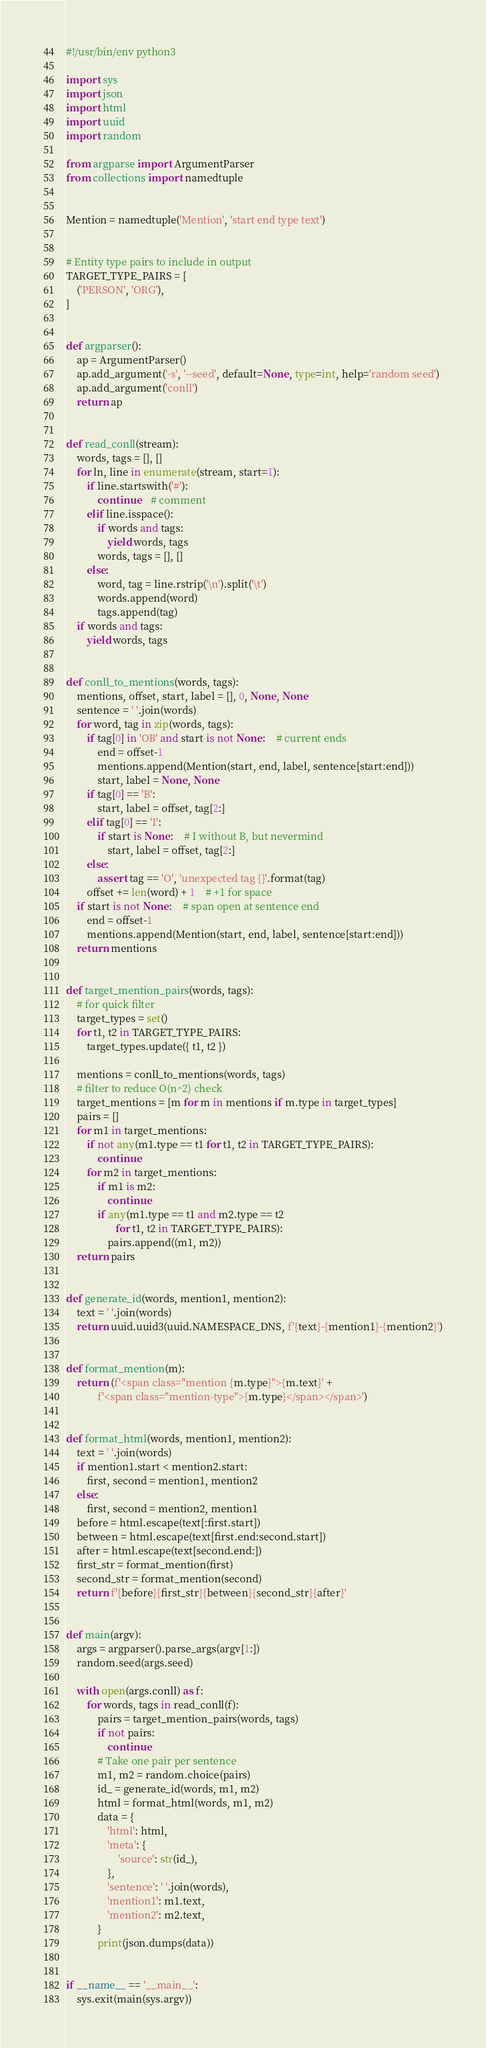<code> <loc_0><loc_0><loc_500><loc_500><_Python_>#!/usr/bin/env python3

import sys
import json
import html
import uuid
import random

from argparse import ArgumentParser
from collections import namedtuple


Mention = namedtuple('Mention', 'start end type text')


# Entity type pairs to include in output
TARGET_TYPE_PAIRS = [
    ('PERSON', 'ORG'),
]


def argparser():
    ap = ArgumentParser()
    ap.add_argument('-s', '--seed', default=None, type=int, help='random seed')
    ap.add_argument('conll')
    return ap


def read_conll(stream):
    words, tags = [], []
    for ln, line in enumerate(stream, start=1):
        if line.startswith('#'):
            continue    # comment
        elif line.isspace():
            if words and tags:
                yield words, tags
            words, tags = [], []
        else:
            word, tag = line.rstrip('\n').split('\t')
            words.append(word)
            tags.append(tag)
    if words and tags:
        yield words, tags


def conll_to_mentions(words, tags):
    mentions, offset, start, label = [], 0, None, None
    sentence = ' '.join(words)
    for word, tag in zip(words, tags):
        if tag[0] in 'OB' and start is not None:    # current ends
            end = offset-1
            mentions.append(Mention(start, end, label, sentence[start:end]))
            start, label = None, None
        if tag[0] == 'B':
            start, label = offset, tag[2:]
        elif tag[0] == 'I':
            if start is None:    # I without B, but nevermind
                start, label = offset, tag[2:]
        else:
            assert tag == 'O', 'unexpected tag {}'.format(tag)
        offset += len(word) + 1    # +1 for space
    if start is not None:    # span open at sentence end
        end = offset-1
        mentions.append(Mention(start, end, label, sentence[start:end]))
    return mentions


def target_mention_pairs(words, tags):
    # for quick filter
    target_types = set()
    for t1, t2 in TARGET_TYPE_PAIRS:
        target_types.update({ t1, t2 })

    mentions = conll_to_mentions(words, tags)
    # filter to reduce O(n^2) check
    target_mentions = [m for m in mentions if m.type in target_types]
    pairs = []
    for m1 in target_mentions:
        if not any(m1.type == t1 for t1, t2 in TARGET_TYPE_PAIRS):
            continue
        for m2 in target_mentions:
            if m1 is m2:
                continue
            if any(m1.type == t1 and m2.type == t2
                   for t1, t2 in TARGET_TYPE_PAIRS):
                pairs.append((m1, m2))
    return pairs


def generate_id(words, mention1, mention2):
    text = ' '.join(words)
    return uuid.uuid3(uuid.NAMESPACE_DNS, f'{text}-{mention1}-{mention2}')


def format_mention(m):
    return (f'<span class="mention {m.type}">{m.text}' +
            f'<span class="mention-type">{m.type}</span></span>')


def format_html(words, mention1, mention2):
    text = ' '.join(words)
    if mention1.start < mention2.start:
        first, second = mention1, mention2
    else:
        first, second = mention2, mention1
    before = html.escape(text[:first.start])
    between = html.escape(text[first.end:second.start])
    after = html.escape(text[second.end:])
    first_str = format_mention(first)
    second_str = format_mention(second)
    return f'{before}{first_str}{between}{second_str}{after}'


def main(argv):
    args = argparser().parse_args(argv[1:])
    random.seed(args.seed)
    
    with open(args.conll) as f:
        for words, tags in read_conll(f):
            pairs = target_mention_pairs(words, tags)
            if not pairs:
                continue
            # Take one pair per sentence
            m1, m2 = random.choice(pairs)
            id_ = generate_id(words, m1, m2)
            html = format_html(words, m1, m2)
            data = {
                'html': html,
                'meta': {
                    'source': str(id_),
                },
                'sentence': ' '.join(words),
                'mention1': m1.text,
                'mention2': m2.text,
            }
            print(json.dumps(data))
            

if __name__ == '__main__':
    sys.exit(main(sys.argv))
</code> 